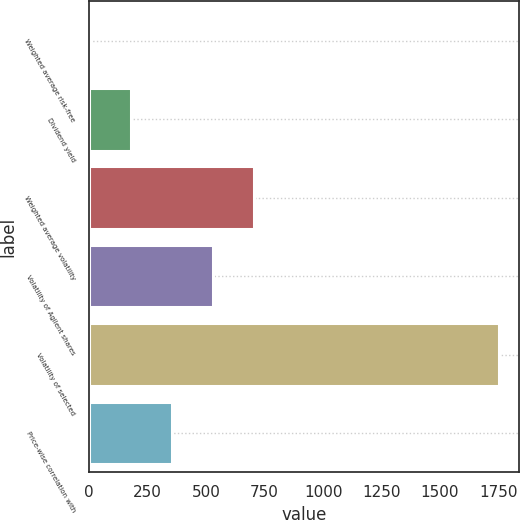<chart> <loc_0><loc_0><loc_500><loc_500><bar_chart><fcel>Weighted average risk-free<fcel>Dividend yield<fcel>Weighted average volatility<fcel>Volatility of Agilent shares<fcel>Volatility of selected<fcel>Price-wise correlation with<nl><fcel>3.16<fcel>178.04<fcel>702.68<fcel>527.8<fcel>1752<fcel>352.92<nl></chart> 